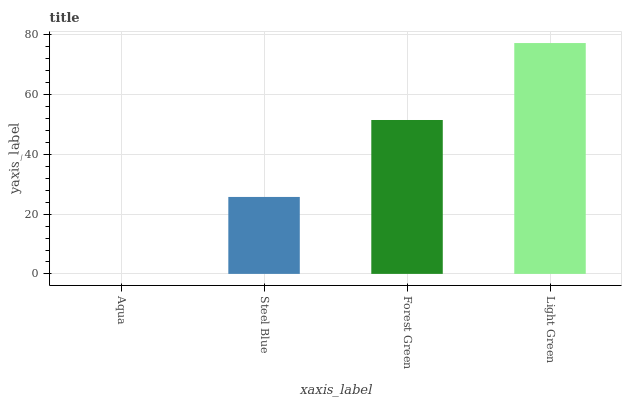Is Aqua the minimum?
Answer yes or no. Yes. Is Light Green the maximum?
Answer yes or no. Yes. Is Steel Blue the minimum?
Answer yes or no. No. Is Steel Blue the maximum?
Answer yes or no. No. Is Steel Blue greater than Aqua?
Answer yes or no. Yes. Is Aqua less than Steel Blue?
Answer yes or no. Yes. Is Aqua greater than Steel Blue?
Answer yes or no. No. Is Steel Blue less than Aqua?
Answer yes or no. No. Is Forest Green the high median?
Answer yes or no. Yes. Is Steel Blue the low median?
Answer yes or no. Yes. Is Steel Blue the high median?
Answer yes or no. No. Is Forest Green the low median?
Answer yes or no. No. 